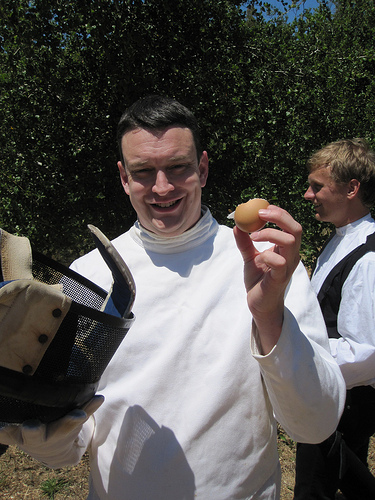<image>
Is the man next to the tree? No. The man is not positioned next to the tree. They are located in different areas of the scene. 